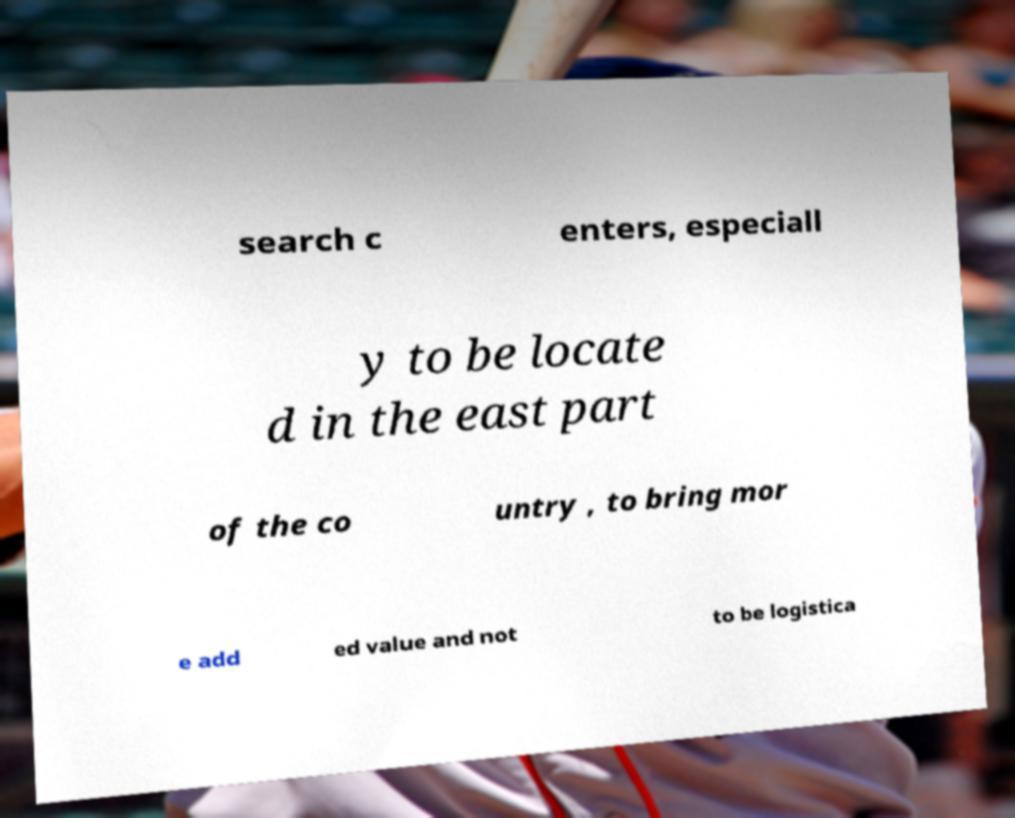Can you read and provide the text displayed in the image?This photo seems to have some interesting text. Can you extract and type it out for me? search c enters, especiall y to be locate d in the east part of the co untry , to bring mor e add ed value and not to be logistica 